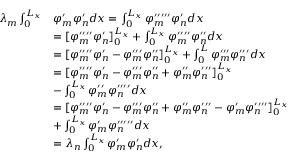<formula> <loc_0><loc_0><loc_500><loc_500>\begin{array} { r l } { \lambda _ { m } \int _ { 0 } ^ { L _ { x } } } & { \varphi _ { m } ^ { \prime } \varphi _ { n } ^ { \prime } d x = \int _ { 0 } ^ { L _ { x } } \varphi _ { m } ^ { \prime \prime \prime \prime \prime } \varphi _ { n } ^ { \prime } d x } \\ & { = [ \varphi _ { m } ^ { \prime \prime \prime \prime } \varphi _ { n } ^ { \prime } ] _ { 0 } ^ { L _ { x } } + \int _ { 0 } ^ { L _ { x } } \varphi _ { m } ^ { \prime \prime \prime \prime } \varphi _ { n } ^ { \prime \prime } d x } \\ & { = [ \varphi _ { m } ^ { \prime \prime \prime \prime } \varphi _ { n } ^ { \prime } - \varphi _ { m } ^ { \prime \prime \prime } \varphi _ { n } ^ { \prime \prime } ] _ { 0 } ^ { L _ { x } } + \int _ { 0 } ^ { L } \varphi _ { m } ^ { \prime \prime \prime } \varphi _ { n } ^ { \prime \prime \prime } d x } \\ & { = [ \varphi _ { m } ^ { \prime \prime \prime \prime } \varphi _ { n } ^ { \prime } - \varphi _ { m } ^ { \prime \prime \prime } \varphi _ { n } ^ { \prime \prime } + \varphi _ { m } ^ { \prime \prime } \varphi _ { n } ^ { \prime \prime \prime } ] _ { 0 } ^ { L _ { x } } } \\ & { - \int _ { 0 } ^ { L _ { x } } \varphi _ { m } ^ { \prime \prime } \varphi _ { n } ^ { \prime \prime \prime \prime } d x } \\ & { = [ \varphi _ { m } ^ { \prime \prime \prime \prime } \varphi _ { n } ^ { \prime } - \varphi _ { m } ^ { \prime \prime \prime } \varphi _ { n } ^ { \prime \prime } + \varphi _ { m } ^ { \prime \prime } \varphi _ { n } ^ { \prime \prime \prime } - \varphi _ { m } ^ { \prime } \varphi _ { n } ^ { \prime \prime \prime \prime } ] _ { 0 } ^ { L _ { x } } } \\ & { + \int _ { 0 } ^ { L _ { x } } \varphi _ { m } ^ { \prime } \varphi _ { n } ^ { \prime \prime \prime \prime \prime } d x } \\ & { = \lambda _ { n } \int _ { 0 } ^ { L _ { x } } \varphi _ { m } ^ { \prime } \varphi _ { n } ^ { \prime } d x , } \end{array}</formula> 